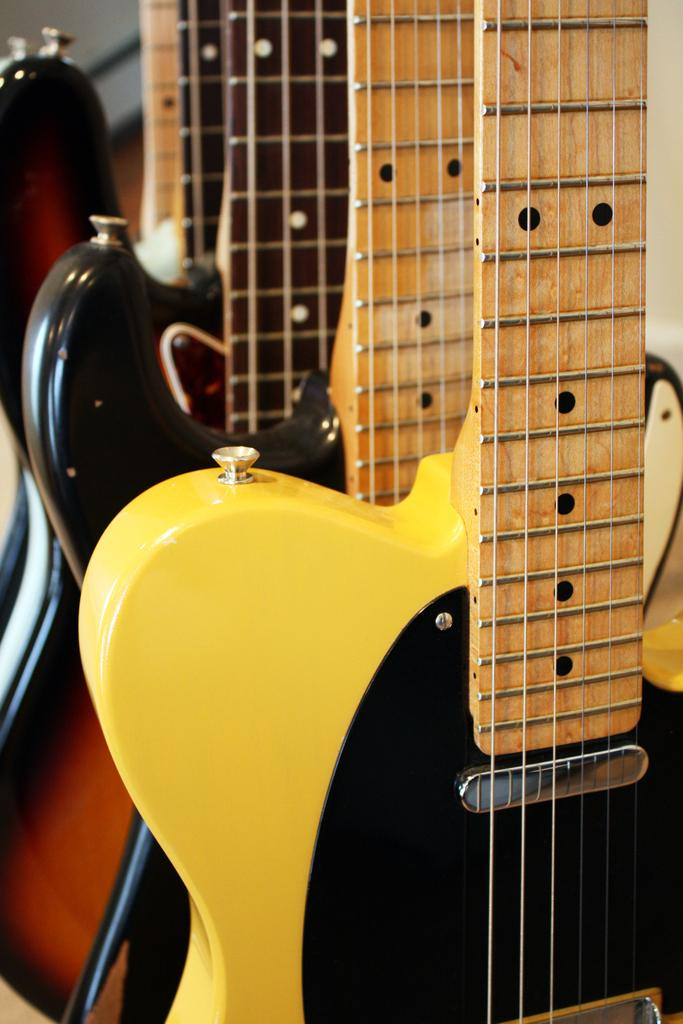How many guitars are visible in the image? There are three guitars in the image. What type of brass instrument can be seen in the image? There is no brass instrument present in the image; it features three guitars. What type of shop is shown in the image? The image does not show a shop; it only features three guitars. 